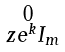Convert formula to latex. <formula><loc_0><loc_0><loc_500><loc_500>\begin{smallmatrix} 0 \\ \ z e ^ { k } I _ { m } \end{smallmatrix}</formula> 